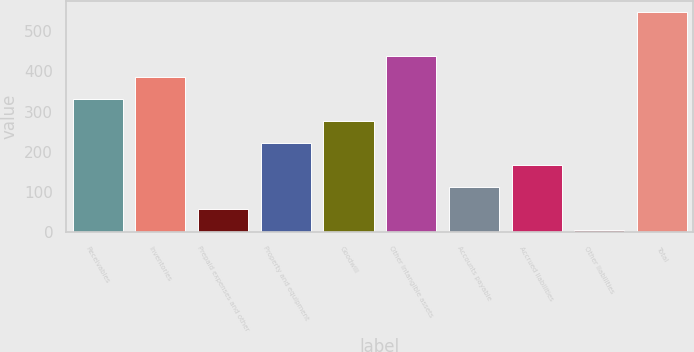<chart> <loc_0><loc_0><loc_500><loc_500><bar_chart><fcel>Receivables<fcel>Inventories<fcel>Prepaid expenses and other<fcel>Property and equipment<fcel>Goodwill<fcel>Other intangible assets<fcel>Accounts payable<fcel>Accrued liabilities<fcel>Other liabilities<fcel>Total<nl><fcel>330.4<fcel>384.8<fcel>58.4<fcel>221.6<fcel>276<fcel>439.2<fcel>112.8<fcel>167.2<fcel>4<fcel>548<nl></chart> 